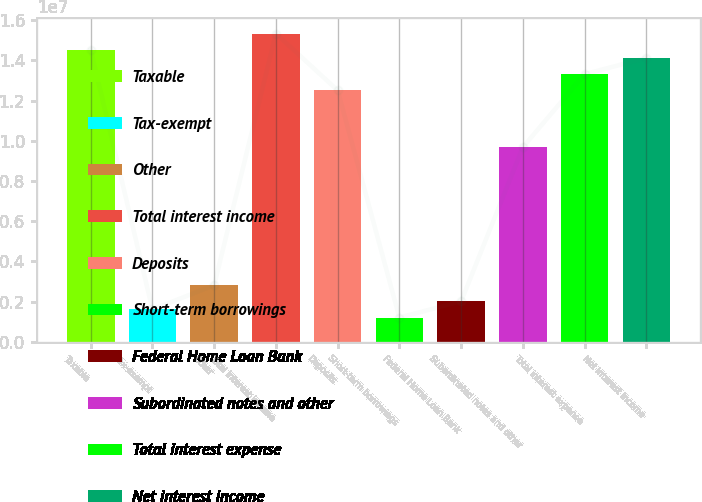<chart> <loc_0><loc_0><loc_500><loc_500><bar_chart><fcel>Taxable<fcel>Tax-exempt<fcel>Other<fcel>Total interest income<fcel>Deposits<fcel>Short-term borrowings<fcel>Federal Home Loan Bank<fcel>Subordinated notes and other<fcel>Total interest expense<fcel>Net interest income<nl><fcel>1.45204e+07<fcel>1.61338e+06<fcel>2.82341e+06<fcel>1.53271e+07<fcel>1.25037e+07<fcel>1.21003e+06<fcel>2.01672e+06<fcel>9.68026e+06<fcel>1.33104e+07<fcel>1.41171e+07<nl></chart> 